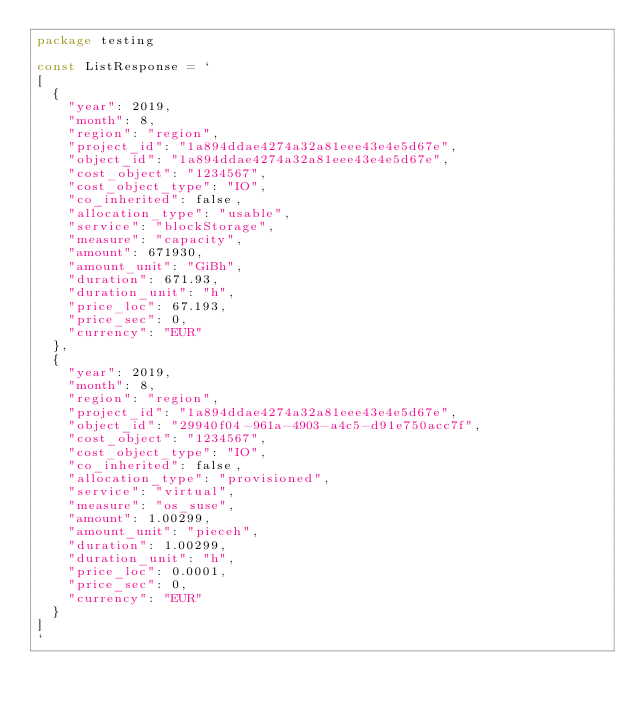Convert code to text. <code><loc_0><loc_0><loc_500><loc_500><_Go_>package testing

const ListResponse = `
[
  {
    "year": 2019,
    "month": 8,
    "region": "region",
    "project_id": "1a894ddae4274a32a81eee43e4e5d67e",
    "object_id": "1a894ddae4274a32a81eee43e4e5d67e",
    "cost_object": "1234567",
    "cost_object_type": "IO",
    "co_inherited": false,
    "allocation_type": "usable",
    "service": "blockStorage",
    "measure": "capacity",
    "amount": 671930,
    "amount_unit": "GiBh",
    "duration": 671.93,
    "duration_unit": "h",
    "price_loc": 67.193,
    "price_sec": 0,
    "currency": "EUR"
  },
  {
    "year": 2019,
    "month": 8,
    "region": "region",
    "project_id": "1a894ddae4274a32a81eee43e4e5d67e",
    "object_id": "29940f04-961a-4903-a4c5-d91e750acc7f",
    "cost_object": "1234567",
    "cost_object_type": "IO",
    "co_inherited": false,
    "allocation_type": "provisioned",
    "service": "virtual",
    "measure": "os_suse",
    "amount": 1.00299,
    "amount_unit": "pieceh",
    "duration": 1.00299,
    "duration_unit": "h",
    "price_loc": 0.0001,
    "price_sec": 0,
    "currency": "EUR"
  }
]
`
</code> 